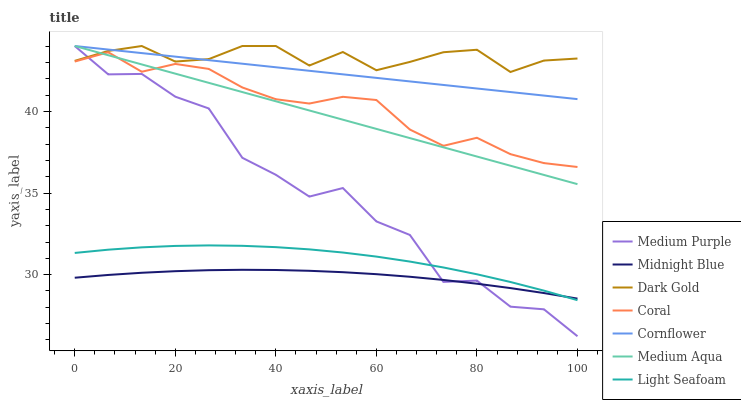Does Midnight Blue have the minimum area under the curve?
Answer yes or no. Yes. Does Dark Gold have the maximum area under the curve?
Answer yes or no. Yes. Does Dark Gold have the minimum area under the curve?
Answer yes or no. No. Does Midnight Blue have the maximum area under the curve?
Answer yes or no. No. Is Cornflower the smoothest?
Answer yes or no. Yes. Is Medium Purple the roughest?
Answer yes or no. Yes. Is Midnight Blue the smoothest?
Answer yes or no. No. Is Midnight Blue the roughest?
Answer yes or no. No. Does Midnight Blue have the lowest value?
Answer yes or no. No. Does Medium Aqua have the highest value?
Answer yes or no. Yes. Does Midnight Blue have the highest value?
Answer yes or no. No. Is Light Seafoam less than Medium Aqua?
Answer yes or no. Yes. Is Cornflower greater than Midnight Blue?
Answer yes or no. Yes. Does Dark Gold intersect Cornflower?
Answer yes or no. Yes. Is Dark Gold less than Cornflower?
Answer yes or no. No. Is Dark Gold greater than Cornflower?
Answer yes or no. No. Does Light Seafoam intersect Medium Aqua?
Answer yes or no. No. 